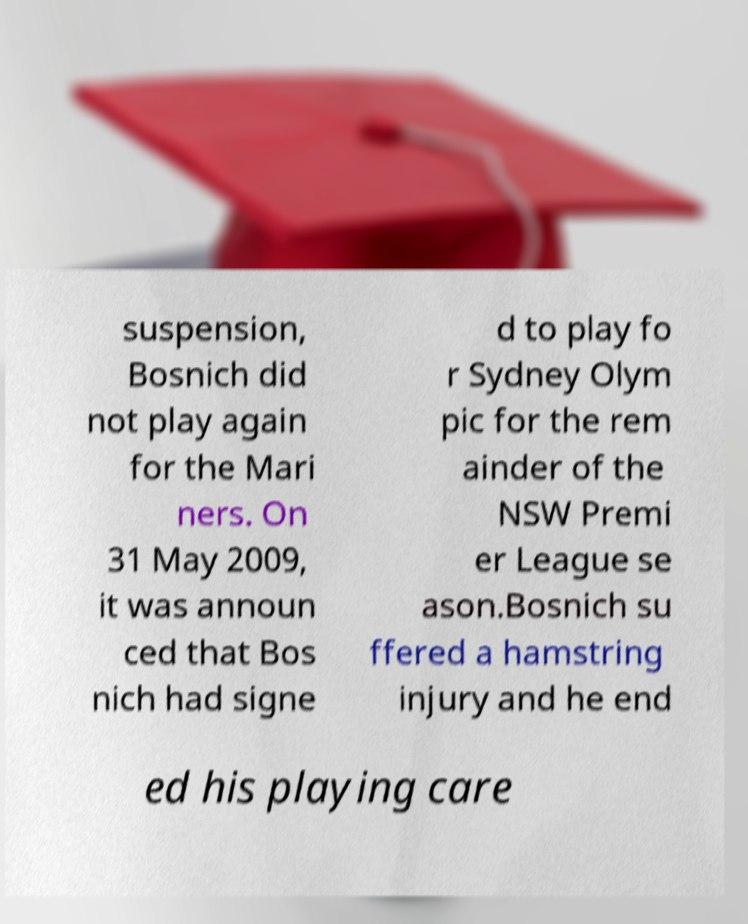Could you extract and type out the text from this image? suspension, Bosnich did not play again for the Mari ners. On 31 May 2009, it was announ ced that Bos nich had signe d to play fo r Sydney Olym pic for the rem ainder of the NSW Premi er League se ason.Bosnich su ffered a hamstring injury and he end ed his playing care 